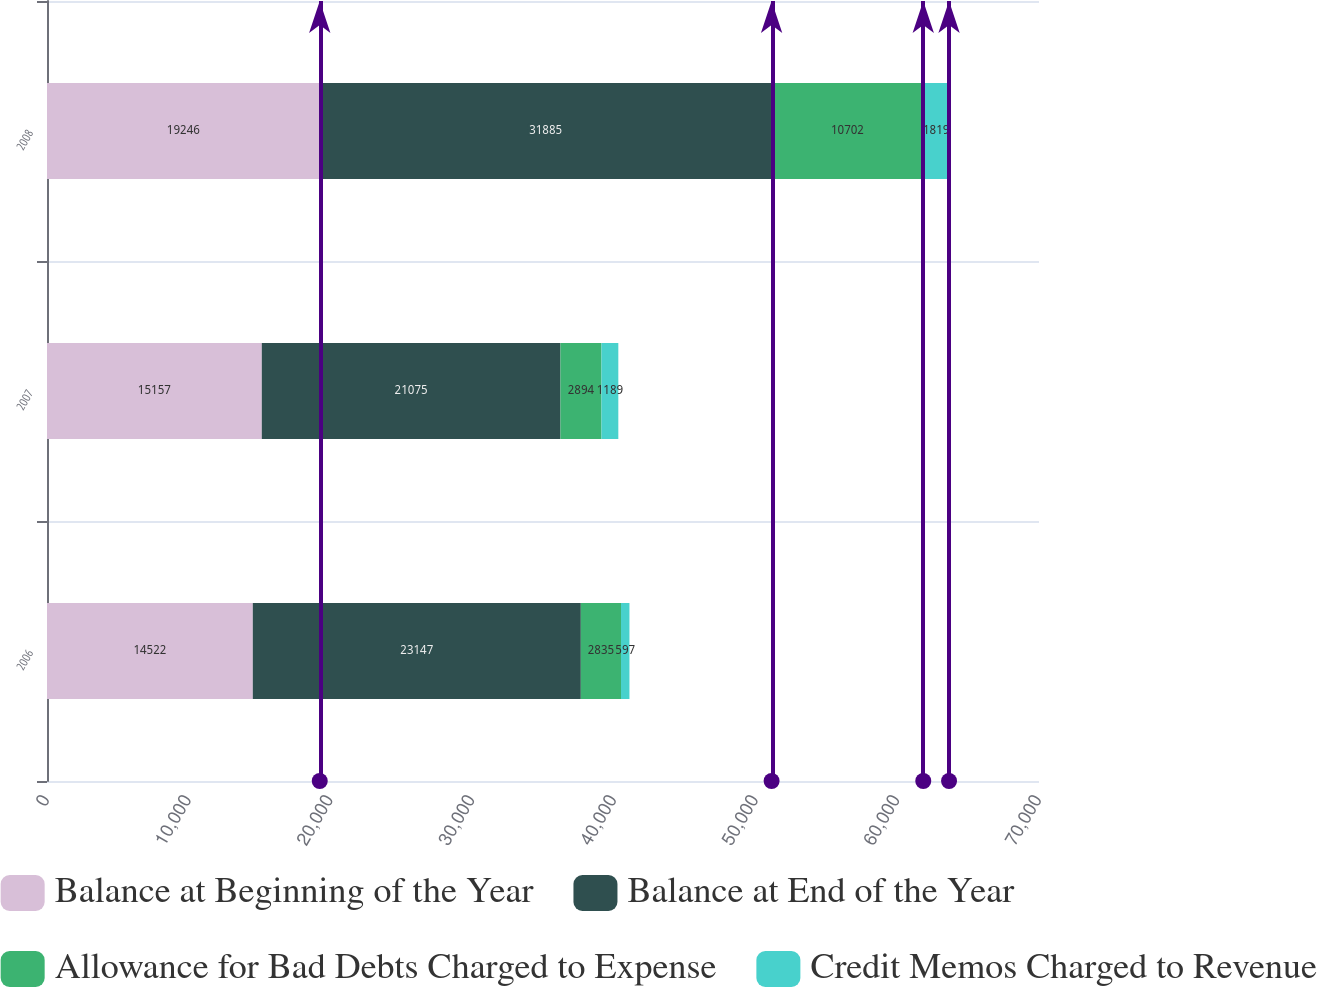Convert chart to OTSL. <chart><loc_0><loc_0><loc_500><loc_500><stacked_bar_chart><ecel><fcel>2006<fcel>2007<fcel>2008<nl><fcel>Balance at Beginning of the Year<fcel>14522<fcel>15157<fcel>19246<nl><fcel>Balance at End of the Year<fcel>23147<fcel>21075<fcel>31885<nl><fcel>Allowance for Bad Debts Charged to Expense<fcel>2835<fcel>2894<fcel>10702<nl><fcel>Credit Memos Charged to Revenue<fcel>597<fcel>1189<fcel>1819<nl></chart> 